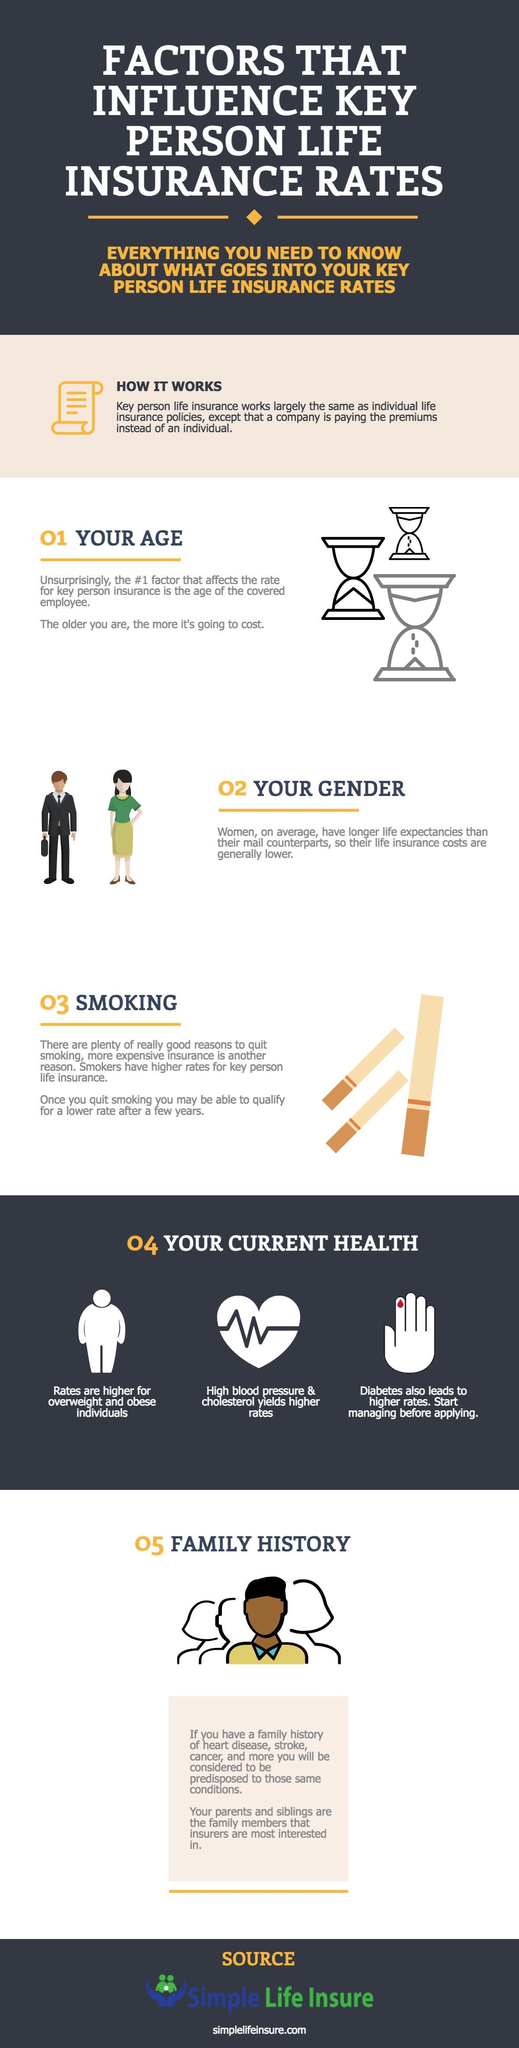What is the third condition mentioned in Current Health that can lead to higher insurance rates?
Answer the question with a short phrase. diabetes Who pays the premium in individual life insurance policies? individual Who have generally lower insurance costs? Women Compared to an older person, how much will insurance cost be for a younger person - more, same or less? less Who is likely to have lowest insurance rates - a smoker, a non-smoker or a person who has just quit smoking? a non-smoker As per factors under Current health, rates are higher for what type of individuals? overweight and obese In which type of insurance policy does a company pay the premiums? Key person life insurance 